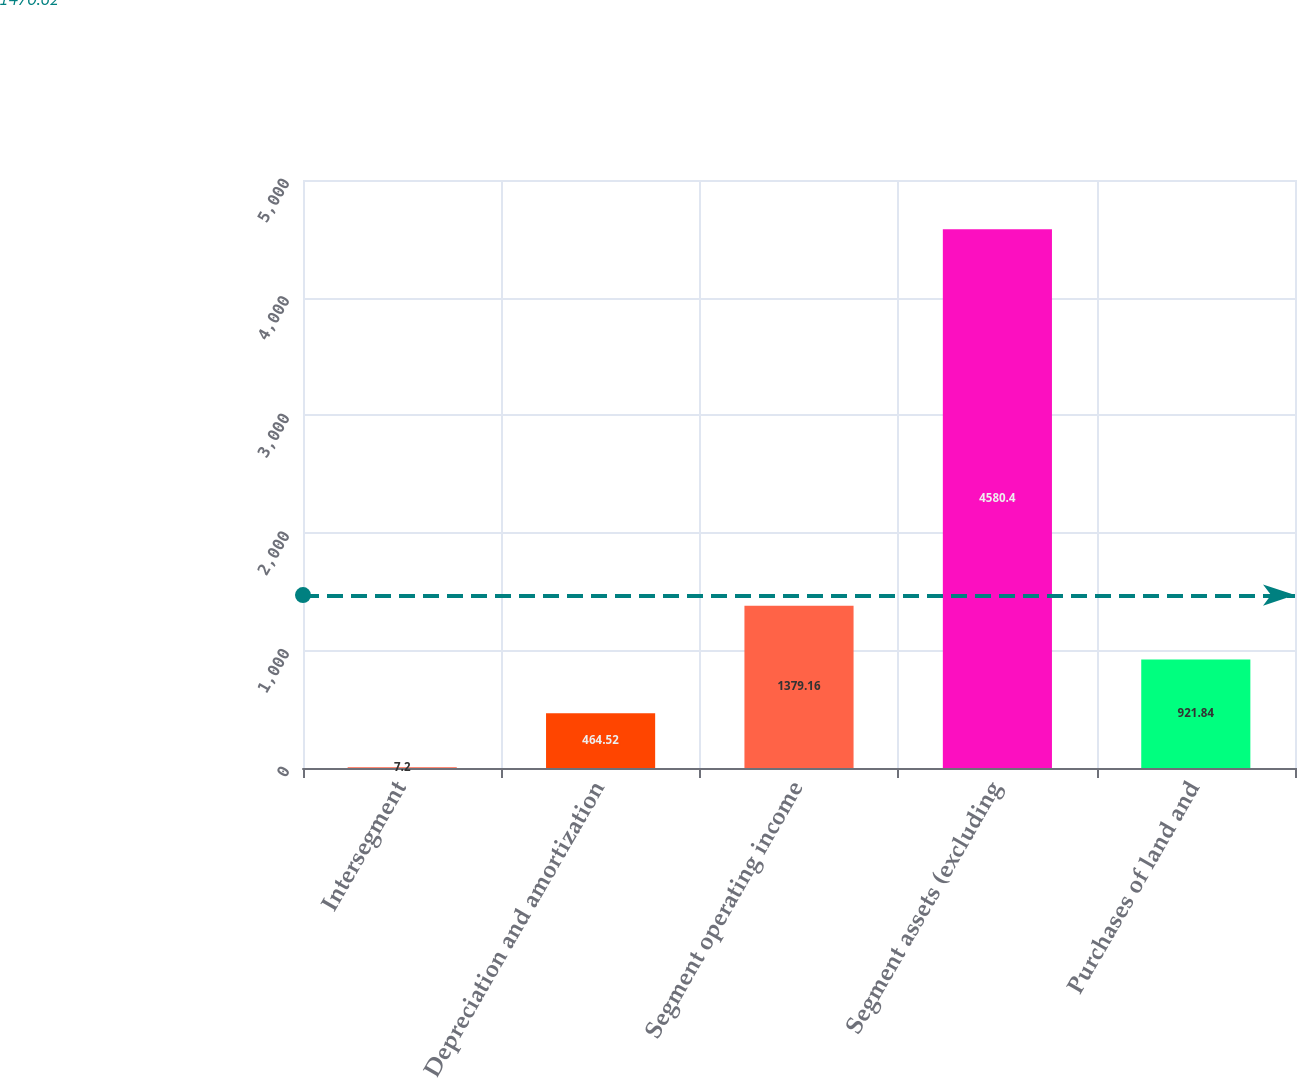Convert chart. <chart><loc_0><loc_0><loc_500><loc_500><bar_chart><fcel>Intersegment<fcel>Depreciation and amortization<fcel>Segment operating income<fcel>Segment assets (excluding<fcel>Purchases of land and<nl><fcel>7.2<fcel>464.52<fcel>1379.16<fcel>4580.4<fcel>921.84<nl></chart> 